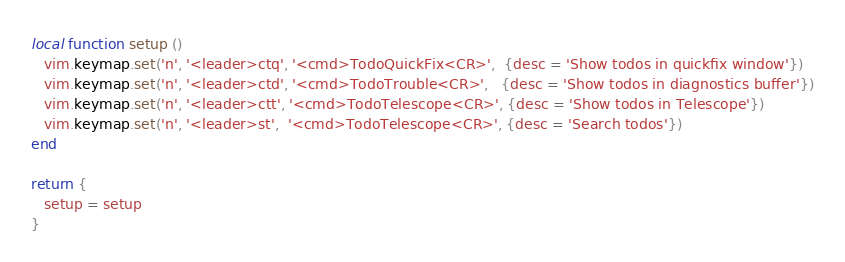Convert code to text. <code><loc_0><loc_0><loc_500><loc_500><_Lua_>local function setup ()
   vim.keymap.set('n', '<leader>ctq', '<cmd>TodoQuickFix<CR>',  {desc = 'Show todos in quickfix window'})
   vim.keymap.set('n', '<leader>ctd', '<cmd>TodoTrouble<CR>',   {desc = 'Show todos in diagnostics buffer'})
   vim.keymap.set('n', '<leader>ctt', '<cmd>TodoTelescope<CR>', {desc = 'Show todos in Telescope'})
   vim.keymap.set('n', '<leader>st',  '<cmd>TodoTelescope<CR>', {desc = 'Search todos'})
end

return {
   setup = setup
}
</code> 